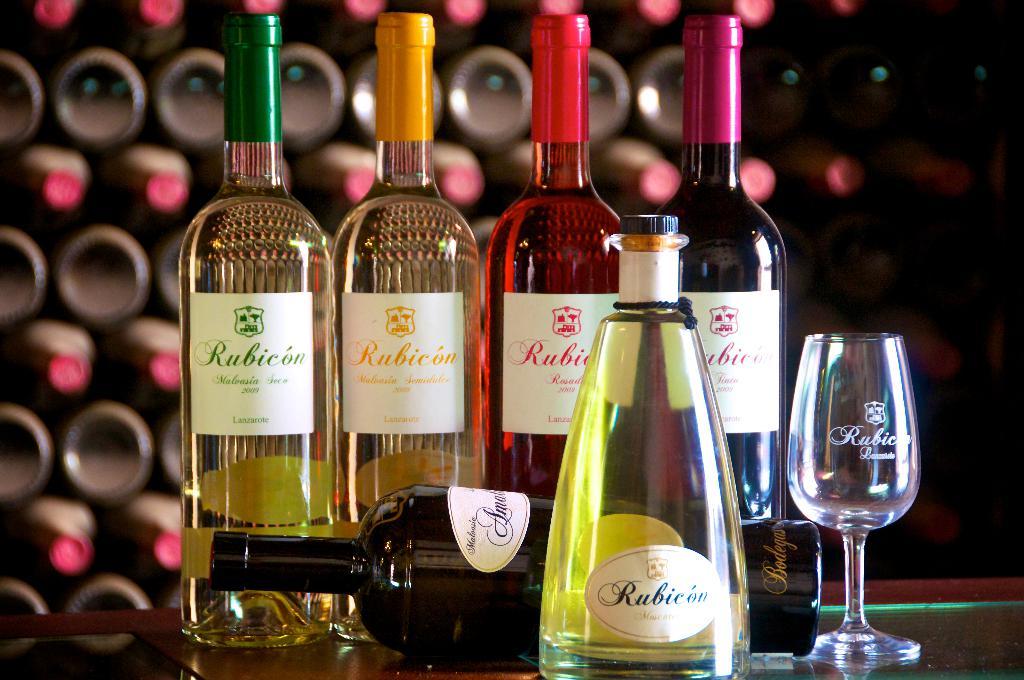What is the brand of alcohol that is being featured?
Provide a short and direct response. Rubicon. What is the year of the green bottle?
Offer a very short reply. 2009. 